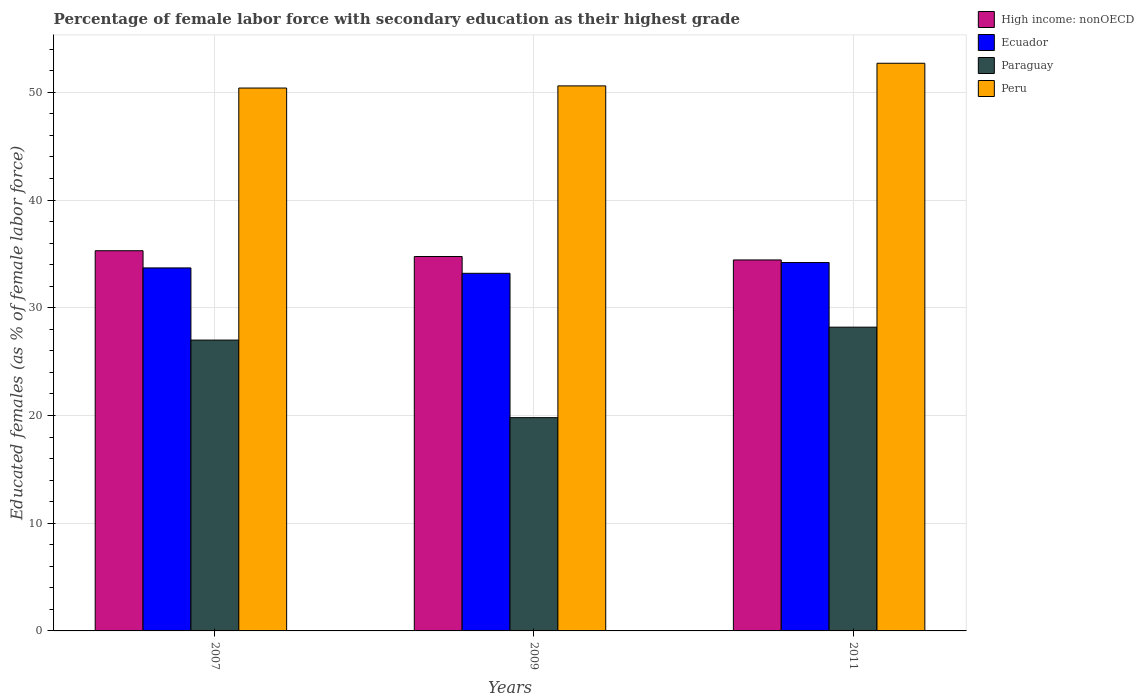How many different coloured bars are there?
Provide a short and direct response. 4. How many groups of bars are there?
Ensure brevity in your answer.  3. Are the number of bars on each tick of the X-axis equal?
Your answer should be compact. Yes. What is the label of the 1st group of bars from the left?
Offer a terse response. 2007. In how many cases, is the number of bars for a given year not equal to the number of legend labels?
Ensure brevity in your answer.  0. What is the percentage of female labor force with secondary education in High income: nonOECD in 2011?
Offer a terse response. 34.44. Across all years, what is the maximum percentage of female labor force with secondary education in Peru?
Provide a short and direct response. 52.7. Across all years, what is the minimum percentage of female labor force with secondary education in Peru?
Give a very brief answer. 50.4. What is the difference between the percentage of female labor force with secondary education in Peru in 2007 and that in 2011?
Your answer should be very brief. -2.3. What is the difference between the percentage of female labor force with secondary education in Paraguay in 2011 and the percentage of female labor force with secondary education in High income: nonOECD in 2009?
Offer a terse response. -6.56. What is the average percentage of female labor force with secondary education in High income: nonOECD per year?
Your answer should be very brief. 34.83. In the year 2011, what is the difference between the percentage of female labor force with secondary education in Paraguay and percentage of female labor force with secondary education in Ecuador?
Keep it short and to the point. -6. In how many years, is the percentage of female labor force with secondary education in Peru greater than 34 %?
Your answer should be compact. 3. What is the ratio of the percentage of female labor force with secondary education in Ecuador in 2009 to that in 2011?
Offer a terse response. 0.97. Is the percentage of female labor force with secondary education in High income: nonOECD in 2007 less than that in 2011?
Your response must be concise. No. What is the difference between the highest and the second highest percentage of female labor force with secondary education in Peru?
Provide a succinct answer. 2.1. What is the difference between the highest and the lowest percentage of female labor force with secondary education in Paraguay?
Your answer should be very brief. 8.4. What does the 2nd bar from the right in 2007 represents?
Your answer should be very brief. Paraguay. How many bars are there?
Keep it short and to the point. 12. How many years are there in the graph?
Make the answer very short. 3. Are the values on the major ticks of Y-axis written in scientific E-notation?
Your response must be concise. No. Does the graph contain any zero values?
Offer a terse response. No. Does the graph contain grids?
Provide a succinct answer. Yes. How many legend labels are there?
Give a very brief answer. 4. How are the legend labels stacked?
Make the answer very short. Vertical. What is the title of the graph?
Give a very brief answer. Percentage of female labor force with secondary education as their highest grade. What is the label or title of the Y-axis?
Make the answer very short. Educated females (as % of female labor force). What is the Educated females (as % of female labor force) of High income: nonOECD in 2007?
Provide a short and direct response. 35.3. What is the Educated females (as % of female labor force) in Ecuador in 2007?
Ensure brevity in your answer.  33.7. What is the Educated females (as % of female labor force) of Peru in 2007?
Your response must be concise. 50.4. What is the Educated females (as % of female labor force) of High income: nonOECD in 2009?
Ensure brevity in your answer.  34.76. What is the Educated females (as % of female labor force) of Ecuador in 2009?
Offer a very short reply. 33.2. What is the Educated females (as % of female labor force) in Paraguay in 2009?
Give a very brief answer. 19.8. What is the Educated females (as % of female labor force) in Peru in 2009?
Keep it short and to the point. 50.6. What is the Educated females (as % of female labor force) of High income: nonOECD in 2011?
Provide a short and direct response. 34.44. What is the Educated females (as % of female labor force) of Ecuador in 2011?
Your answer should be compact. 34.2. What is the Educated females (as % of female labor force) of Paraguay in 2011?
Give a very brief answer. 28.2. What is the Educated females (as % of female labor force) of Peru in 2011?
Your answer should be compact. 52.7. Across all years, what is the maximum Educated females (as % of female labor force) in High income: nonOECD?
Offer a terse response. 35.3. Across all years, what is the maximum Educated females (as % of female labor force) of Ecuador?
Give a very brief answer. 34.2. Across all years, what is the maximum Educated females (as % of female labor force) of Paraguay?
Provide a short and direct response. 28.2. Across all years, what is the maximum Educated females (as % of female labor force) in Peru?
Your response must be concise. 52.7. Across all years, what is the minimum Educated females (as % of female labor force) in High income: nonOECD?
Your answer should be compact. 34.44. Across all years, what is the minimum Educated females (as % of female labor force) in Ecuador?
Provide a succinct answer. 33.2. Across all years, what is the minimum Educated females (as % of female labor force) in Paraguay?
Provide a short and direct response. 19.8. Across all years, what is the minimum Educated females (as % of female labor force) in Peru?
Offer a very short reply. 50.4. What is the total Educated females (as % of female labor force) of High income: nonOECD in the graph?
Your answer should be very brief. 104.49. What is the total Educated females (as % of female labor force) of Ecuador in the graph?
Ensure brevity in your answer.  101.1. What is the total Educated females (as % of female labor force) in Paraguay in the graph?
Your response must be concise. 75. What is the total Educated females (as % of female labor force) in Peru in the graph?
Provide a short and direct response. 153.7. What is the difference between the Educated females (as % of female labor force) in High income: nonOECD in 2007 and that in 2009?
Your response must be concise. 0.54. What is the difference between the Educated females (as % of female labor force) in Paraguay in 2007 and that in 2009?
Offer a terse response. 7.2. What is the difference between the Educated females (as % of female labor force) of High income: nonOECD in 2007 and that in 2011?
Your answer should be very brief. 0.86. What is the difference between the Educated females (as % of female labor force) of Paraguay in 2007 and that in 2011?
Provide a succinct answer. -1.2. What is the difference between the Educated females (as % of female labor force) of Peru in 2007 and that in 2011?
Keep it short and to the point. -2.3. What is the difference between the Educated females (as % of female labor force) in High income: nonOECD in 2009 and that in 2011?
Make the answer very short. 0.32. What is the difference between the Educated females (as % of female labor force) in Ecuador in 2009 and that in 2011?
Your answer should be very brief. -1. What is the difference between the Educated females (as % of female labor force) in High income: nonOECD in 2007 and the Educated females (as % of female labor force) in Ecuador in 2009?
Provide a succinct answer. 2.1. What is the difference between the Educated females (as % of female labor force) of High income: nonOECD in 2007 and the Educated females (as % of female labor force) of Paraguay in 2009?
Your answer should be very brief. 15.5. What is the difference between the Educated females (as % of female labor force) in High income: nonOECD in 2007 and the Educated females (as % of female labor force) in Peru in 2009?
Provide a succinct answer. -15.3. What is the difference between the Educated females (as % of female labor force) of Ecuador in 2007 and the Educated females (as % of female labor force) of Peru in 2009?
Your answer should be compact. -16.9. What is the difference between the Educated females (as % of female labor force) in Paraguay in 2007 and the Educated females (as % of female labor force) in Peru in 2009?
Your answer should be compact. -23.6. What is the difference between the Educated females (as % of female labor force) in High income: nonOECD in 2007 and the Educated females (as % of female labor force) in Ecuador in 2011?
Your response must be concise. 1.1. What is the difference between the Educated females (as % of female labor force) in High income: nonOECD in 2007 and the Educated females (as % of female labor force) in Paraguay in 2011?
Provide a short and direct response. 7.1. What is the difference between the Educated females (as % of female labor force) in High income: nonOECD in 2007 and the Educated females (as % of female labor force) in Peru in 2011?
Keep it short and to the point. -17.4. What is the difference between the Educated females (as % of female labor force) in Ecuador in 2007 and the Educated females (as % of female labor force) in Paraguay in 2011?
Make the answer very short. 5.5. What is the difference between the Educated females (as % of female labor force) of Paraguay in 2007 and the Educated females (as % of female labor force) of Peru in 2011?
Your response must be concise. -25.7. What is the difference between the Educated females (as % of female labor force) of High income: nonOECD in 2009 and the Educated females (as % of female labor force) of Ecuador in 2011?
Your answer should be compact. 0.56. What is the difference between the Educated females (as % of female labor force) in High income: nonOECD in 2009 and the Educated females (as % of female labor force) in Paraguay in 2011?
Give a very brief answer. 6.56. What is the difference between the Educated females (as % of female labor force) in High income: nonOECD in 2009 and the Educated females (as % of female labor force) in Peru in 2011?
Make the answer very short. -17.94. What is the difference between the Educated females (as % of female labor force) of Ecuador in 2009 and the Educated females (as % of female labor force) of Paraguay in 2011?
Offer a very short reply. 5. What is the difference between the Educated females (as % of female labor force) in Ecuador in 2009 and the Educated females (as % of female labor force) in Peru in 2011?
Your answer should be compact. -19.5. What is the difference between the Educated females (as % of female labor force) of Paraguay in 2009 and the Educated females (as % of female labor force) of Peru in 2011?
Keep it short and to the point. -32.9. What is the average Educated females (as % of female labor force) in High income: nonOECD per year?
Provide a short and direct response. 34.83. What is the average Educated females (as % of female labor force) in Ecuador per year?
Ensure brevity in your answer.  33.7. What is the average Educated females (as % of female labor force) of Paraguay per year?
Offer a very short reply. 25. What is the average Educated females (as % of female labor force) of Peru per year?
Your answer should be compact. 51.23. In the year 2007, what is the difference between the Educated females (as % of female labor force) of High income: nonOECD and Educated females (as % of female labor force) of Ecuador?
Offer a very short reply. 1.6. In the year 2007, what is the difference between the Educated females (as % of female labor force) in High income: nonOECD and Educated females (as % of female labor force) in Paraguay?
Ensure brevity in your answer.  8.3. In the year 2007, what is the difference between the Educated females (as % of female labor force) in High income: nonOECD and Educated females (as % of female labor force) in Peru?
Provide a short and direct response. -15.1. In the year 2007, what is the difference between the Educated females (as % of female labor force) of Ecuador and Educated females (as % of female labor force) of Peru?
Keep it short and to the point. -16.7. In the year 2007, what is the difference between the Educated females (as % of female labor force) in Paraguay and Educated females (as % of female labor force) in Peru?
Offer a very short reply. -23.4. In the year 2009, what is the difference between the Educated females (as % of female labor force) of High income: nonOECD and Educated females (as % of female labor force) of Ecuador?
Give a very brief answer. 1.56. In the year 2009, what is the difference between the Educated females (as % of female labor force) in High income: nonOECD and Educated females (as % of female labor force) in Paraguay?
Your response must be concise. 14.96. In the year 2009, what is the difference between the Educated females (as % of female labor force) in High income: nonOECD and Educated females (as % of female labor force) in Peru?
Your answer should be compact. -15.84. In the year 2009, what is the difference between the Educated females (as % of female labor force) of Ecuador and Educated females (as % of female labor force) of Peru?
Provide a succinct answer. -17.4. In the year 2009, what is the difference between the Educated females (as % of female labor force) of Paraguay and Educated females (as % of female labor force) of Peru?
Offer a very short reply. -30.8. In the year 2011, what is the difference between the Educated females (as % of female labor force) in High income: nonOECD and Educated females (as % of female labor force) in Ecuador?
Ensure brevity in your answer.  0.24. In the year 2011, what is the difference between the Educated females (as % of female labor force) in High income: nonOECD and Educated females (as % of female labor force) in Paraguay?
Make the answer very short. 6.24. In the year 2011, what is the difference between the Educated females (as % of female labor force) of High income: nonOECD and Educated females (as % of female labor force) of Peru?
Ensure brevity in your answer.  -18.26. In the year 2011, what is the difference between the Educated females (as % of female labor force) in Ecuador and Educated females (as % of female labor force) in Paraguay?
Give a very brief answer. 6. In the year 2011, what is the difference between the Educated females (as % of female labor force) of Ecuador and Educated females (as % of female labor force) of Peru?
Give a very brief answer. -18.5. In the year 2011, what is the difference between the Educated females (as % of female labor force) in Paraguay and Educated females (as % of female labor force) in Peru?
Offer a terse response. -24.5. What is the ratio of the Educated females (as % of female labor force) in High income: nonOECD in 2007 to that in 2009?
Your answer should be very brief. 1.02. What is the ratio of the Educated females (as % of female labor force) in Ecuador in 2007 to that in 2009?
Ensure brevity in your answer.  1.02. What is the ratio of the Educated females (as % of female labor force) of Paraguay in 2007 to that in 2009?
Provide a short and direct response. 1.36. What is the ratio of the Educated females (as % of female labor force) in High income: nonOECD in 2007 to that in 2011?
Your response must be concise. 1.02. What is the ratio of the Educated females (as % of female labor force) in Ecuador in 2007 to that in 2011?
Make the answer very short. 0.99. What is the ratio of the Educated females (as % of female labor force) of Paraguay in 2007 to that in 2011?
Ensure brevity in your answer.  0.96. What is the ratio of the Educated females (as % of female labor force) of Peru in 2007 to that in 2011?
Your answer should be very brief. 0.96. What is the ratio of the Educated females (as % of female labor force) of High income: nonOECD in 2009 to that in 2011?
Ensure brevity in your answer.  1.01. What is the ratio of the Educated females (as % of female labor force) in Ecuador in 2009 to that in 2011?
Give a very brief answer. 0.97. What is the ratio of the Educated females (as % of female labor force) in Paraguay in 2009 to that in 2011?
Offer a terse response. 0.7. What is the ratio of the Educated females (as % of female labor force) of Peru in 2009 to that in 2011?
Offer a terse response. 0.96. What is the difference between the highest and the second highest Educated females (as % of female labor force) of High income: nonOECD?
Provide a succinct answer. 0.54. What is the difference between the highest and the second highest Educated females (as % of female labor force) in Ecuador?
Offer a terse response. 0.5. What is the difference between the highest and the second highest Educated females (as % of female labor force) of Paraguay?
Give a very brief answer. 1.2. What is the difference between the highest and the lowest Educated females (as % of female labor force) in High income: nonOECD?
Make the answer very short. 0.86. What is the difference between the highest and the lowest Educated females (as % of female labor force) in Paraguay?
Your response must be concise. 8.4. 